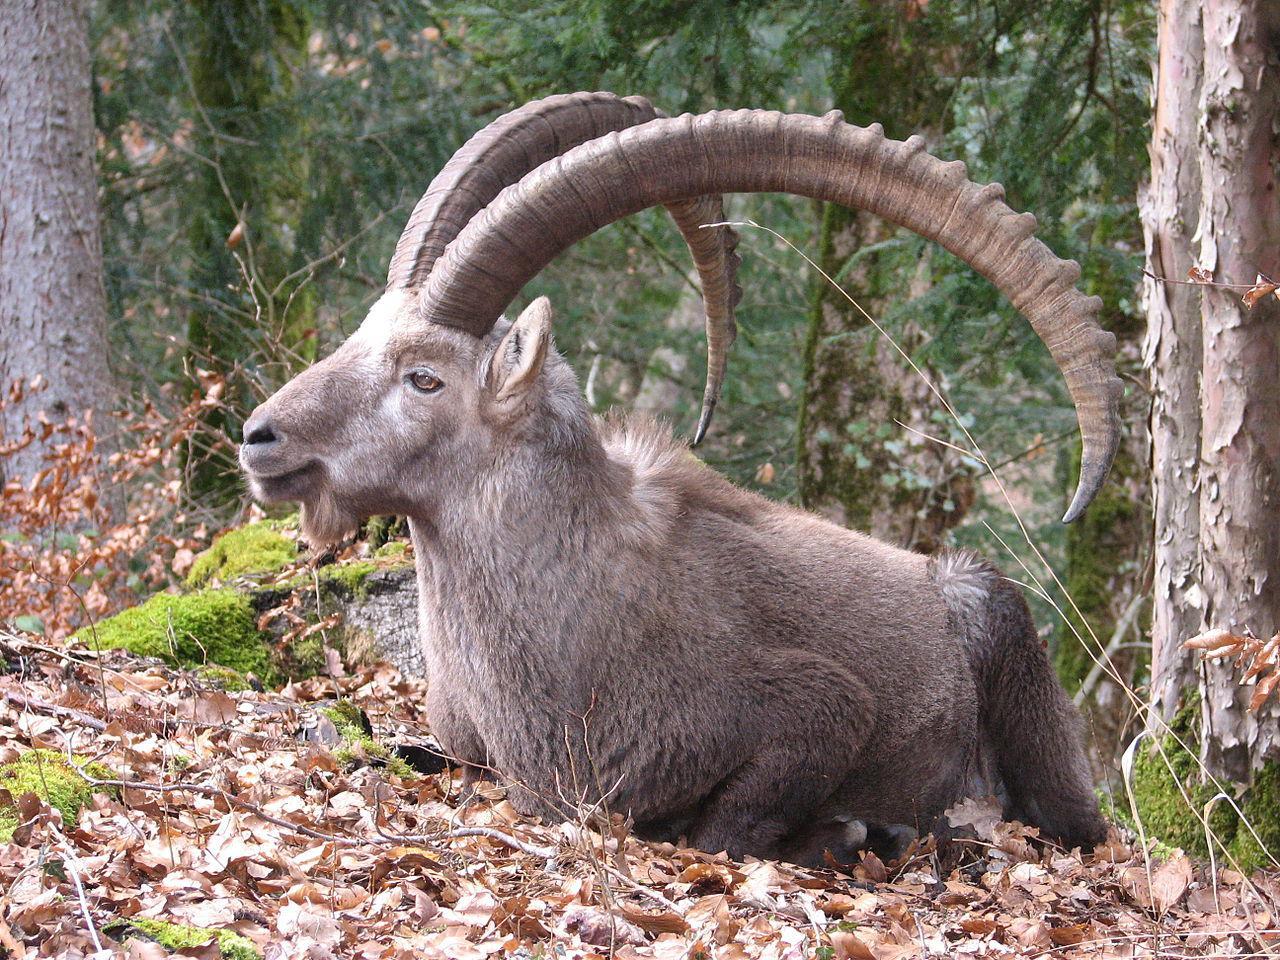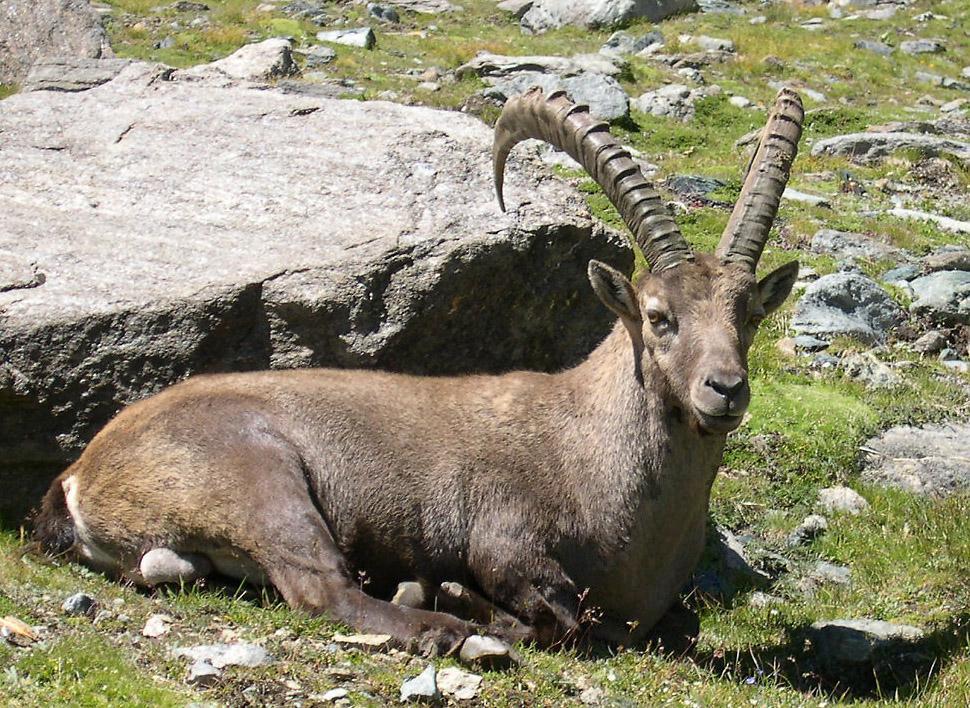The first image is the image on the left, the second image is the image on the right. Analyze the images presented: Is the assertion "At least one image shows a horned animal resting on the ground with feet visible, tucked underneath." valid? Answer yes or no. Yes. 